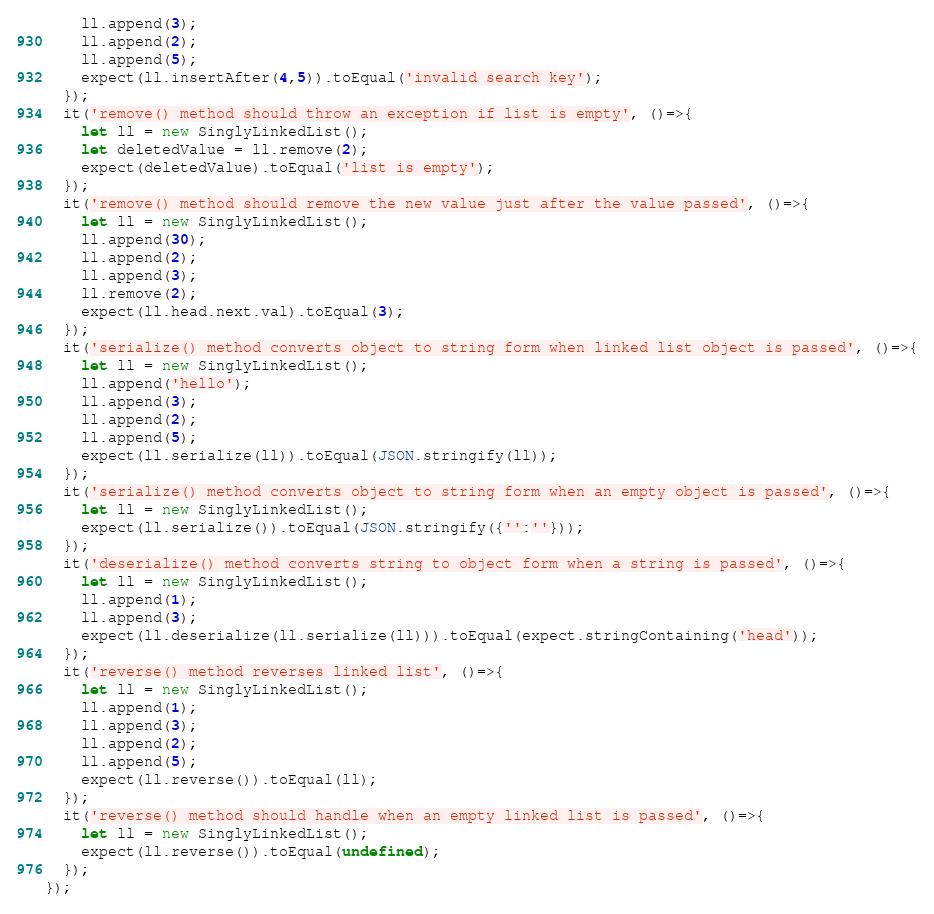<code> <loc_0><loc_0><loc_500><loc_500><_JavaScript_>    ll.append(3);
    ll.append(2);
    ll.append(5);
    expect(ll.insertAfter(4,5)).toEqual('invalid search key');
  });  
  it('remove() method should throw an exception if list is empty', ()=>{
    let ll = new SinglyLinkedList();
    let deletedValue = ll.remove(2);
    expect(deletedValue).toEqual('list is empty');
  });
  it('remove() method should remove the new value just after the value passed', ()=>{
    let ll = new SinglyLinkedList();
    ll.append(30);
    ll.append(2);
    ll.append(3);
    ll.remove(2);
    expect(ll.head.next.val).toEqual(3);
  });
  it('serialize() method converts object to string form when linked list object is passed', ()=>{
    let ll = new SinglyLinkedList();
    ll.append('hello');
    ll.append(3);
    ll.append(2);
    ll.append(5);
    expect(ll.serialize(ll)).toEqual(JSON.stringify(ll));
  });
  it('serialize() method converts object to string form when an empty object is passed', ()=>{
    let ll = new SinglyLinkedList();
    expect(ll.serialize()).toEqual(JSON.stringify({'':''}));
  });
  it('deserialize() method converts string to object form when a string is passed', ()=>{
    let ll = new SinglyLinkedList();
    ll.append(1);
    ll.append(3);
    expect(ll.deserialize(ll.serialize(ll))).toEqual(expect.stringContaining('head'));
  });
  it('reverse() method reverses linked list', ()=>{
    let ll = new SinglyLinkedList();
    ll.append(1);
    ll.append(3);
    ll.append(2);
    ll.append(5);
    expect(ll.reverse()).toEqual(ll);
  });
  it('reverse() method should handle when an empty linked list is passed', ()=>{
    let ll = new SinglyLinkedList();
    expect(ll.reverse()).toEqual(undefined);
  });
});</code> 